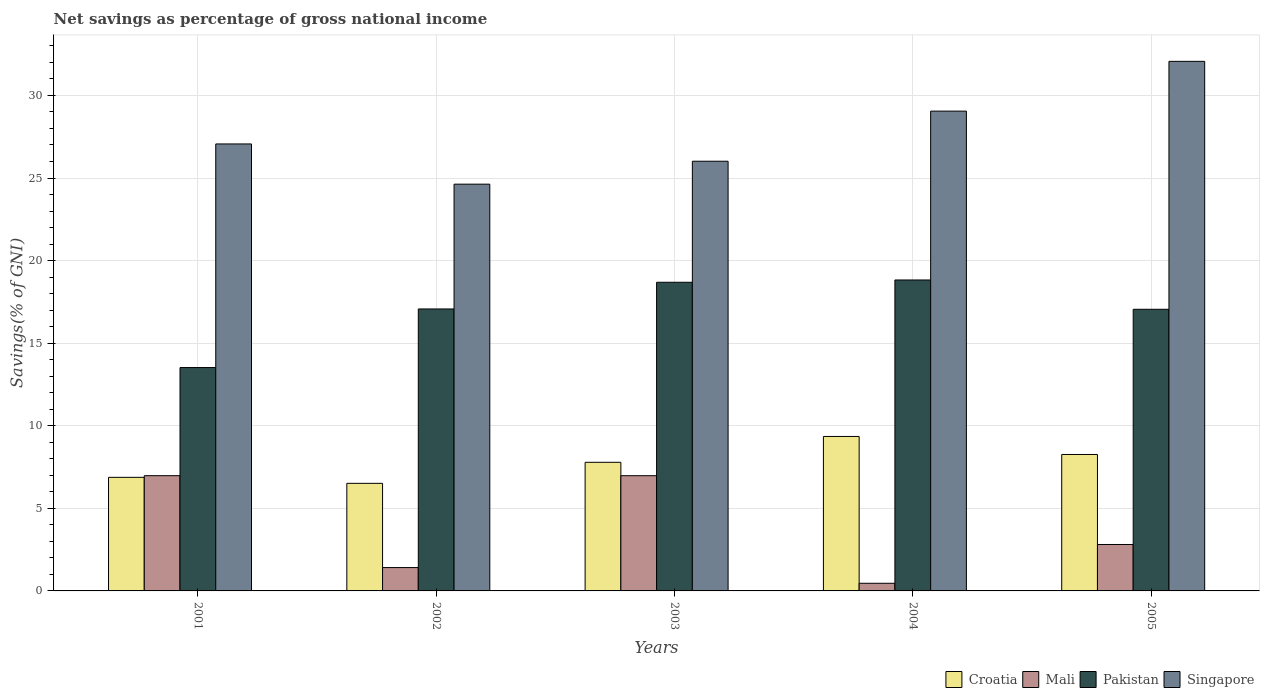How many bars are there on the 3rd tick from the right?
Keep it short and to the point. 4. What is the label of the 1st group of bars from the left?
Offer a terse response. 2001. In how many cases, is the number of bars for a given year not equal to the number of legend labels?
Your answer should be compact. 0. What is the total savings in Mali in 2003?
Make the answer very short. 6.98. Across all years, what is the maximum total savings in Singapore?
Offer a terse response. 32.06. Across all years, what is the minimum total savings in Singapore?
Offer a very short reply. 24.63. In which year was the total savings in Mali maximum?
Your response must be concise. 2001. What is the total total savings in Pakistan in the graph?
Your answer should be very brief. 85.16. What is the difference between the total savings in Singapore in 2003 and that in 2004?
Provide a succinct answer. -3.03. What is the difference between the total savings in Singapore in 2005 and the total savings in Mali in 2004?
Provide a short and direct response. 31.6. What is the average total savings in Croatia per year?
Keep it short and to the point. 7.76. In the year 2005, what is the difference between the total savings in Singapore and total savings in Croatia?
Provide a short and direct response. 23.8. What is the ratio of the total savings in Singapore in 2001 to that in 2005?
Provide a short and direct response. 0.84. Is the total savings in Croatia in 2002 less than that in 2003?
Offer a terse response. Yes. Is the difference between the total savings in Singapore in 2002 and 2005 greater than the difference between the total savings in Croatia in 2002 and 2005?
Your answer should be very brief. No. What is the difference between the highest and the second highest total savings in Croatia?
Ensure brevity in your answer.  1.09. What is the difference between the highest and the lowest total savings in Singapore?
Your answer should be compact. 7.44. Is it the case that in every year, the sum of the total savings in Mali and total savings in Pakistan is greater than the total savings in Singapore?
Provide a short and direct response. No. How many bars are there?
Ensure brevity in your answer.  20. How are the legend labels stacked?
Ensure brevity in your answer.  Horizontal. What is the title of the graph?
Your response must be concise. Net savings as percentage of gross national income. Does "Israel" appear as one of the legend labels in the graph?
Your answer should be very brief. No. What is the label or title of the Y-axis?
Your answer should be very brief. Savings(% of GNI). What is the Savings(% of GNI) in Croatia in 2001?
Your answer should be very brief. 6.88. What is the Savings(% of GNI) of Mali in 2001?
Your response must be concise. 6.98. What is the Savings(% of GNI) in Pakistan in 2001?
Your answer should be very brief. 13.52. What is the Savings(% of GNI) in Singapore in 2001?
Your answer should be compact. 27.06. What is the Savings(% of GNI) in Croatia in 2002?
Keep it short and to the point. 6.51. What is the Savings(% of GNI) of Mali in 2002?
Provide a succinct answer. 1.41. What is the Savings(% of GNI) in Pakistan in 2002?
Keep it short and to the point. 17.07. What is the Savings(% of GNI) of Singapore in 2002?
Your response must be concise. 24.63. What is the Savings(% of GNI) of Croatia in 2003?
Your response must be concise. 7.79. What is the Savings(% of GNI) in Mali in 2003?
Provide a short and direct response. 6.98. What is the Savings(% of GNI) in Pakistan in 2003?
Your answer should be very brief. 18.69. What is the Savings(% of GNI) in Singapore in 2003?
Your answer should be very brief. 26.02. What is the Savings(% of GNI) of Croatia in 2004?
Provide a succinct answer. 9.35. What is the Savings(% of GNI) in Mali in 2004?
Keep it short and to the point. 0.46. What is the Savings(% of GNI) of Pakistan in 2004?
Provide a short and direct response. 18.83. What is the Savings(% of GNI) in Singapore in 2004?
Provide a short and direct response. 29.05. What is the Savings(% of GNI) of Croatia in 2005?
Provide a succinct answer. 8.26. What is the Savings(% of GNI) in Mali in 2005?
Your response must be concise. 2.81. What is the Savings(% of GNI) of Pakistan in 2005?
Make the answer very short. 17.05. What is the Savings(% of GNI) in Singapore in 2005?
Your response must be concise. 32.06. Across all years, what is the maximum Savings(% of GNI) of Croatia?
Give a very brief answer. 9.35. Across all years, what is the maximum Savings(% of GNI) of Mali?
Your response must be concise. 6.98. Across all years, what is the maximum Savings(% of GNI) of Pakistan?
Your response must be concise. 18.83. Across all years, what is the maximum Savings(% of GNI) in Singapore?
Your answer should be compact. 32.06. Across all years, what is the minimum Savings(% of GNI) of Croatia?
Provide a succinct answer. 6.51. Across all years, what is the minimum Savings(% of GNI) in Mali?
Your answer should be compact. 0.46. Across all years, what is the minimum Savings(% of GNI) in Pakistan?
Provide a short and direct response. 13.52. Across all years, what is the minimum Savings(% of GNI) in Singapore?
Your answer should be very brief. 24.63. What is the total Savings(% of GNI) of Croatia in the graph?
Give a very brief answer. 38.79. What is the total Savings(% of GNI) in Mali in the graph?
Give a very brief answer. 18.64. What is the total Savings(% of GNI) of Pakistan in the graph?
Give a very brief answer. 85.16. What is the total Savings(% of GNI) in Singapore in the graph?
Your response must be concise. 138.82. What is the difference between the Savings(% of GNI) in Croatia in 2001 and that in 2002?
Provide a short and direct response. 0.36. What is the difference between the Savings(% of GNI) in Mali in 2001 and that in 2002?
Give a very brief answer. 5.56. What is the difference between the Savings(% of GNI) in Pakistan in 2001 and that in 2002?
Give a very brief answer. -3.55. What is the difference between the Savings(% of GNI) in Singapore in 2001 and that in 2002?
Your response must be concise. 2.44. What is the difference between the Savings(% of GNI) in Croatia in 2001 and that in 2003?
Offer a very short reply. -0.91. What is the difference between the Savings(% of GNI) of Pakistan in 2001 and that in 2003?
Your answer should be very brief. -5.16. What is the difference between the Savings(% of GNI) of Singapore in 2001 and that in 2003?
Make the answer very short. 1.05. What is the difference between the Savings(% of GNI) in Croatia in 2001 and that in 2004?
Ensure brevity in your answer.  -2.47. What is the difference between the Savings(% of GNI) in Mali in 2001 and that in 2004?
Your response must be concise. 6.51. What is the difference between the Savings(% of GNI) of Pakistan in 2001 and that in 2004?
Your response must be concise. -5.3. What is the difference between the Savings(% of GNI) of Singapore in 2001 and that in 2004?
Give a very brief answer. -1.99. What is the difference between the Savings(% of GNI) in Croatia in 2001 and that in 2005?
Give a very brief answer. -1.38. What is the difference between the Savings(% of GNI) in Mali in 2001 and that in 2005?
Provide a succinct answer. 4.17. What is the difference between the Savings(% of GNI) of Pakistan in 2001 and that in 2005?
Give a very brief answer. -3.53. What is the difference between the Savings(% of GNI) in Singapore in 2001 and that in 2005?
Offer a very short reply. -5. What is the difference between the Savings(% of GNI) of Croatia in 2002 and that in 2003?
Your answer should be very brief. -1.27. What is the difference between the Savings(% of GNI) of Mali in 2002 and that in 2003?
Keep it short and to the point. -5.56. What is the difference between the Savings(% of GNI) of Pakistan in 2002 and that in 2003?
Give a very brief answer. -1.62. What is the difference between the Savings(% of GNI) of Singapore in 2002 and that in 2003?
Give a very brief answer. -1.39. What is the difference between the Savings(% of GNI) of Croatia in 2002 and that in 2004?
Give a very brief answer. -2.84. What is the difference between the Savings(% of GNI) of Mali in 2002 and that in 2004?
Your answer should be very brief. 0.95. What is the difference between the Savings(% of GNI) in Pakistan in 2002 and that in 2004?
Your answer should be compact. -1.75. What is the difference between the Savings(% of GNI) of Singapore in 2002 and that in 2004?
Your answer should be compact. -4.42. What is the difference between the Savings(% of GNI) in Croatia in 2002 and that in 2005?
Offer a terse response. -1.75. What is the difference between the Savings(% of GNI) of Mali in 2002 and that in 2005?
Ensure brevity in your answer.  -1.4. What is the difference between the Savings(% of GNI) of Pakistan in 2002 and that in 2005?
Your answer should be compact. 0.02. What is the difference between the Savings(% of GNI) of Singapore in 2002 and that in 2005?
Ensure brevity in your answer.  -7.44. What is the difference between the Savings(% of GNI) of Croatia in 2003 and that in 2004?
Your response must be concise. -1.56. What is the difference between the Savings(% of GNI) in Mali in 2003 and that in 2004?
Your response must be concise. 6.51. What is the difference between the Savings(% of GNI) of Pakistan in 2003 and that in 2004?
Ensure brevity in your answer.  -0.14. What is the difference between the Savings(% of GNI) in Singapore in 2003 and that in 2004?
Give a very brief answer. -3.03. What is the difference between the Savings(% of GNI) of Croatia in 2003 and that in 2005?
Provide a short and direct response. -0.47. What is the difference between the Savings(% of GNI) of Mali in 2003 and that in 2005?
Provide a short and direct response. 4.17. What is the difference between the Savings(% of GNI) of Pakistan in 2003 and that in 2005?
Make the answer very short. 1.64. What is the difference between the Savings(% of GNI) in Singapore in 2003 and that in 2005?
Offer a very short reply. -6.05. What is the difference between the Savings(% of GNI) of Croatia in 2004 and that in 2005?
Offer a terse response. 1.09. What is the difference between the Savings(% of GNI) of Mali in 2004 and that in 2005?
Your answer should be very brief. -2.35. What is the difference between the Savings(% of GNI) in Pakistan in 2004 and that in 2005?
Your answer should be compact. 1.77. What is the difference between the Savings(% of GNI) of Singapore in 2004 and that in 2005?
Your response must be concise. -3.01. What is the difference between the Savings(% of GNI) in Croatia in 2001 and the Savings(% of GNI) in Mali in 2002?
Offer a terse response. 5.46. What is the difference between the Savings(% of GNI) in Croatia in 2001 and the Savings(% of GNI) in Pakistan in 2002?
Make the answer very short. -10.2. What is the difference between the Savings(% of GNI) of Croatia in 2001 and the Savings(% of GNI) of Singapore in 2002?
Offer a terse response. -17.75. What is the difference between the Savings(% of GNI) of Mali in 2001 and the Savings(% of GNI) of Pakistan in 2002?
Provide a short and direct response. -10.09. What is the difference between the Savings(% of GNI) in Mali in 2001 and the Savings(% of GNI) in Singapore in 2002?
Offer a terse response. -17.65. What is the difference between the Savings(% of GNI) of Pakistan in 2001 and the Savings(% of GNI) of Singapore in 2002?
Provide a short and direct response. -11.1. What is the difference between the Savings(% of GNI) in Croatia in 2001 and the Savings(% of GNI) in Mali in 2003?
Provide a succinct answer. -0.1. What is the difference between the Savings(% of GNI) in Croatia in 2001 and the Savings(% of GNI) in Pakistan in 2003?
Make the answer very short. -11.81. What is the difference between the Savings(% of GNI) of Croatia in 2001 and the Savings(% of GNI) of Singapore in 2003?
Make the answer very short. -19.14. What is the difference between the Savings(% of GNI) in Mali in 2001 and the Savings(% of GNI) in Pakistan in 2003?
Give a very brief answer. -11.71. What is the difference between the Savings(% of GNI) of Mali in 2001 and the Savings(% of GNI) of Singapore in 2003?
Provide a short and direct response. -19.04. What is the difference between the Savings(% of GNI) in Pakistan in 2001 and the Savings(% of GNI) in Singapore in 2003?
Ensure brevity in your answer.  -12.49. What is the difference between the Savings(% of GNI) in Croatia in 2001 and the Savings(% of GNI) in Mali in 2004?
Offer a terse response. 6.41. What is the difference between the Savings(% of GNI) in Croatia in 2001 and the Savings(% of GNI) in Pakistan in 2004?
Ensure brevity in your answer.  -11.95. What is the difference between the Savings(% of GNI) of Croatia in 2001 and the Savings(% of GNI) of Singapore in 2004?
Keep it short and to the point. -22.17. What is the difference between the Savings(% of GNI) of Mali in 2001 and the Savings(% of GNI) of Pakistan in 2004?
Provide a succinct answer. -11.85. What is the difference between the Savings(% of GNI) of Mali in 2001 and the Savings(% of GNI) of Singapore in 2004?
Give a very brief answer. -22.07. What is the difference between the Savings(% of GNI) in Pakistan in 2001 and the Savings(% of GNI) in Singapore in 2004?
Provide a short and direct response. -15.53. What is the difference between the Savings(% of GNI) in Croatia in 2001 and the Savings(% of GNI) in Mali in 2005?
Make the answer very short. 4.07. What is the difference between the Savings(% of GNI) of Croatia in 2001 and the Savings(% of GNI) of Pakistan in 2005?
Ensure brevity in your answer.  -10.18. What is the difference between the Savings(% of GNI) in Croatia in 2001 and the Savings(% of GNI) in Singapore in 2005?
Give a very brief answer. -25.19. What is the difference between the Savings(% of GNI) of Mali in 2001 and the Savings(% of GNI) of Pakistan in 2005?
Your answer should be compact. -10.07. What is the difference between the Savings(% of GNI) in Mali in 2001 and the Savings(% of GNI) in Singapore in 2005?
Make the answer very short. -25.09. What is the difference between the Savings(% of GNI) in Pakistan in 2001 and the Savings(% of GNI) in Singapore in 2005?
Give a very brief answer. -18.54. What is the difference between the Savings(% of GNI) of Croatia in 2002 and the Savings(% of GNI) of Mali in 2003?
Make the answer very short. -0.46. What is the difference between the Savings(% of GNI) in Croatia in 2002 and the Savings(% of GNI) in Pakistan in 2003?
Keep it short and to the point. -12.17. What is the difference between the Savings(% of GNI) in Croatia in 2002 and the Savings(% of GNI) in Singapore in 2003?
Keep it short and to the point. -19.5. What is the difference between the Savings(% of GNI) in Mali in 2002 and the Savings(% of GNI) in Pakistan in 2003?
Ensure brevity in your answer.  -17.27. What is the difference between the Savings(% of GNI) in Mali in 2002 and the Savings(% of GNI) in Singapore in 2003?
Offer a terse response. -24.6. What is the difference between the Savings(% of GNI) of Pakistan in 2002 and the Savings(% of GNI) of Singapore in 2003?
Your answer should be very brief. -8.94. What is the difference between the Savings(% of GNI) of Croatia in 2002 and the Savings(% of GNI) of Mali in 2004?
Provide a short and direct response. 6.05. What is the difference between the Savings(% of GNI) in Croatia in 2002 and the Savings(% of GNI) in Pakistan in 2004?
Give a very brief answer. -12.31. What is the difference between the Savings(% of GNI) of Croatia in 2002 and the Savings(% of GNI) of Singapore in 2004?
Your answer should be compact. -22.54. What is the difference between the Savings(% of GNI) in Mali in 2002 and the Savings(% of GNI) in Pakistan in 2004?
Your answer should be compact. -17.41. What is the difference between the Savings(% of GNI) in Mali in 2002 and the Savings(% of GNI) in Singapore in 2004?
Give a very brief answer. -27.64. What is the difference between the Savings(% of GNI) in Pakistan in 2002 and the Savings(% of GNI) in Singapore in 2004?
Give a very brief answer. -11.98. What is the difference between the Savings(% of GNI) in Croatia in 2002 and the Savings(% of GNI) in Mali in 2005?
Offer a very short reply. 3.7. What is the difference between the Savings(% of GNI) in Croatia in 2002 and the Savings(% of GNI) in Pakistan in 2005?
Provide a short and direct response. -10.54. What is the difference between the Savings(% of GNI) of Croatia in 2002 and the Savings(% of GNI) of Singapore in 2005?
Your answer should be very brief. -25.55. What is the difference between the Savings(% of GNI) in Mali in 2002 and the Savings(% of GNI) in Pakistan in 2005?
Provide a succinct answer. -15.64. What is the difference between the Savings(% of GNI) of Mali in 2002 and the Savings(% of GNI) of Singapore in 2005?
Provide a succinct answer. -30.65. What is the difference between the Savings(% of GNI) of Pakistan in 2002 and the Savings(% of GNI) of Singapore in 2005?
Ensure brevity in your answer.  -14.99. What is the difference between the Savings(% of GNI) in Croatia in 2003 and the Savings(% of GNI) in Mali in 2004?
Your answer should be compact. 7.32. What is the difference between the Savings(% of GNI) in Croatia in 2003 and the Savings(% of GNI) in Pakistan in 2004?
Your answer should be compact. -11.04. What is the difference between the Savings(% of GNI) in Croatia in 2003 and the Savings(% of GNI) in Singapore in 2004?
Provide a succinct answer. -21.26. What is the difference between the Savings(% of GNI) in Mali in 2003 and the Savings(% of GNI) in Pakistan in 2004?
Your answer should be very brief. -11.85. What is the difference between the Savings(% of GNI) of Mali in 2003 and the Savings(% of GNI) of Singapore in 2004?
Make the answer very short. -22.07. What is the difference between the Savings(% of GNI) in Pakistan in 2003 and the Savings(% of GNI) in Singapore in 2004?
Keep it short and to the point. -10.36. What is the difference between the Savings(% of GNI) in Croatia in 2003 and the Savings(% of GNI) in Mali in 2005?
Your response must be concise. 4.98. What is the difference between the Savings(% of GNI) in Croatia in 2003 and the Savings(% of GNI) in Pakistan in 2005?
Your response must be concise. -9.27. What is the difference between the Savings(% of GNI) of Croatia in 2003 and the Savings(% of GNI) of Singapore in 2005?
Your answer should be very brief. -24.28. What is the difference between the Savings(% of GNI) of Mali in 2003 and the Savings(% of GNI) of Pakistan in 2005?
Give a very brief answer. -10.08. What is the difference between the Savings(% of GNI) in Mali in 2003 and the Savings(% of GNI) in Singapore in 2005?
Ensure brevity in your answer.  -25.09. What is the difference between the Savings(% of GNI) in Pakistan in 2003 and the Savings(% of GNI) in Singapore in 2005?
Offer a terse response. -13.38. What is the difference between the Savings(% of GNI) of Croatia in 2004 and the Savings(% of GNI) of Mali in 2005?
Your response must be concise. 6.54. What is the difference between the Savings(% of GNI) in Croatia in 2004 and the Savings(% of GNI) in Pakistan in 2005?
Provide a succinct answer. -7.7. What is the difference between the Savings(% of GNI) of Croatia in 2004 and the Savings(% of GNI) of Singapore in 2005?
Provide a succinct answer. -22.71. What is the difference between the Savings(% of GNI) of Mali in 2004 and the Savings(% of GNI) of Pakistan in 2005?
Provide a short and direct response. -16.59. What is the difference between the Savings(% of GNI) of Mali in 2004 and the Savings(% of GNI) of Singapore in 2005?
Your answer should be compact. -31.6. What is the difference between the Savings(% of GNI) in Pakistan in 2004 and the Savings(% of GNI) in Singapore in 2005?
Keep it short and to the point. -13.24. What is the average Savings(% of GNI) in Croatia per year?
Offer a terse response. 7.76. What is the average Savings(% of GNI) in Mali per year?
Your answer should be very brief. 3.73. What is the average Savings(% of GNI) in Pakistan per year?
Your answer should be compact. 17.03. What is the average Savings(% of GNI) in Singapore per year?
Provide a succinct answer. 27.76. In the year 2001, what is the difference between the Savings(% of GNI) of Croatia and Savings(% of GNI) of Mali?
Make the answer very short. -0.1. In the year 2001, what is the difference between the Savings(% of GNI) of Croatia and Savings(% of GNI) of Pakistan?
Keep it short and to the point. -6.65. In the year 2001, what is the difference between the Savings(% of GNI) in Croatia and Savings(% of GNI) in Singapore?
Ensure brevity in your answer.  -20.19. In the year 2001, what is the difference between the Savings(% of GNI) in Mali and Savings(% of GNI) in Pakistan?
Your response must be concise. -6.55. In the year 2001, what is the difference between the Savings(% of GNI) in Mali and Savings(% of GNI) in Singapore?
Provide a short and direct response. -20.09. In the year 2001, what is the difference between the Savings(% of GNI) in Pakistan and Savings(% of GNI) in Singapore?
Make the answer very short. -13.54. In the year 2002, what is the difference between the Savings(% of GNI) in Croatia and Savings(% of GNI) in Mali?
Your answer should be compact. 5.1. In the year 2002, what is the difference between the Savings(% of GNI) in Croatia and Savings(% of GNI) in Pakistan?
Provide a short and direct response. -10.56. In the year 2002, what is the difference between the Savings(% of GNI) of Croatia and Savings(% of GNI) of Singapore?
Your answer should be compact. -18.11. In the year 2002, what is the difference between the Savings(% of GNI) of Mali and Savings(% of GNI) of Pakistan?
Your answer should be very brief. -15.66. In the year 2002, what is the difference between the Savings(% of GNI) of Mali and Savings(% of GNI) of Singapore?
Offer a terse response. -23.21. In the year 2002, what is the difference between the Savings(% of GNI) of Pakistan and Savings(% of GNI) of Singapore?
Your response must be concise. -7.56. In the year 2003, what is the difference between the Savings(% of GNI) in Croatia and Savings(% of GNI) in Mali?
Provide a short and direct response. 0.81. In the year 2003, what is the difference between the Savings(% of GNI) of Croatia and Savings(% of GNI) of Pakistan?
Ensure brevity in your answer.  -10.9. In the year 2003, what is the difference between the Savings(% of GNI) of Croatia and Savings(% of GNI) of Singapore?
Make the answer very short. -18.23. In the year 2003, what is the difference between the Savings(% of GNI) of Mali and Savings(% of GNI) of Pakistan?
Make the answer very short. -11.71. In the year 2003, what is the difference between the Savings(% of GNI) of Mali and Savings(% of GNI) of Singapore?
Give a very brief answer. -19.04. In the year 2003, what is the difference between the Savings(% of GNI) of Pakistan and Savings(% of GNI) of Singapore?
Your answer should be compact. -7.33. In the year 2004, what is the difference between the Savings(% of GNI) of Croatia and Savings(% of GNI) of Mali?
Provide a succinct answer. 8.89. In the year 2004, what is the difference between the Savings(% of GNI) in Croatia and Savings(% of GNI) in Pakistan?
Make the answer very short. -9.47. In the year 2004, what is the difference between the Savings(% of GNI) of Croatia and Savings(% of GNI) of Singapore?
Offer a terse response. -19.7. In the year 2004, what is the difference between the Savings(% of GNI) of Mali and Savings(% of GNI) of Pakistan?
Ensure brevity in your answer.  -18.36. In the year 2004, what is the difference between the Savings(% of GNI) of Mali and Savings(% of GNI) of Singapore?
Provide a short and direct response. -28.59. In the year 2004, what is the difference between the Savings(% of GNI) of Pakistan and Savings(% of GNI) of Singapore?
Give a very brief answer. -10.22. In the year 2005, what is the difference between the Savings(% of GNI) in Croatia and Savings(% of GNI) in Mali?
Offer a terse response. 5.45. In the year 2005, what is the difference between the Savings(% of GNI) of Croatia and Savings(% of GNI) of Pakistan?
Your answer should be very brief. -8.79. In the year 2005, what is the difference between the Savings(% of GNI) in Croatia and Savings(% of GNI) in Singapore?
Offer a very short reply. -23.8. In the year 2005, what is the difference between the Savings(% of GNI) in Mali and Savings(% of GNI) in Pakistan?
Keep it short and to the point. -14.24. In the year 2005, what is the difference between the Savings(% of GNI) of Mali and Savings(% of GNI) of Singapore?
Ensure brevity in your answer.  -29.25. In the year 2005, what is the difference between the Savings(% of GNI) of Pakistan and Savings(% of GNI) of Singapore?
Keep it short and to the point. -15.01. What is the ratio of the Savings(% of GNI) of Croatia in 2001 to that in 2002?
Offer a terse response. 1.06. What is the ratio of the Savings(% of GNI) of Mali in 2001 to that in 2002?
Your answer should be very brief. 4.93. What is the ratio of the Savings(% of GNI) in Pakistan in 2001 to that in 2002?
Your answer should be compact. 0.79. What is the ratio of the Savings(% of GNI) in Singapore in 2001 to that in 2002?
Ensure brevity in your answer.  1.1. What is the ratio of the Savings(% of GNI) of Croatia in 2001 to that in 2003?
Your answer should be compact. 0.88. What is the ratio of the Savings(% of GNI) of Mali in 2001 to that in 2003?
Give a very brief answer. 1. What is the ratio of the Savings(% of GNI) in Pakistan in 2001 to that in 2003?
Ensure brevity in your answer.  0.72. What is the ratio of the Savings(% of GNI) of Singapore in 2001 to that in 2003?
Provide a succinct answer. 1.04. What is the ratio of the Savings(% of GNI) of Croatia in 2001 to that in 2004?
Provide a succinct answer. 0.74. What is the ratio of the Savings(% of GNI) of Mali in 2001 to that in 2004?
Your response must be concise. 15.08. What is the ratio of the Savings(% of GNI) in Pakistan in 2001 to that in 2004?
Offer a terse response. 0.72. What is the ratio of the Savings(% of GNI) of Singapore in 2001 to that in 2004?
Provide a short and direct response. 0.93. What is the ratio of the Savings(% of GNI) in Croatia in 2001 to that in 2005?
Provide a short and direct response. 0.83. What is the ratio of the Savings(% of GNI) of Mali in 2001 to that in 2005?
Your response must be concise. 2.48. What is the ratio of the Savings(% of GNI) in Pakistan in 2001 to that in 2005?
Make the answer very short. 0.79. What is the ratio of the Savings(% of GNI) in Singapore in 2001 to that in 2005?
Make the answer very short. 0.84. What is the ratio of the Savings(% of GNI) of Croatia in 2002 to that in 2003?
Offer a very short reply. 0.84. What is the ratio of the Savings(% of GNI) in Mali in 2002 to that in 2003?
Offer a terse response. 0.2. What is the ratio of the Savings(% of GNI) in Pakistan in 2002 to that in 2003?
Ensure brevity in your answer.  0.91. What is the ratio of the Savings(% of GNI) in Singapore in 2002 to that in 2003?
Your answer should be compact. 0.95. What is the ratio of the Savings(% of GNI) of Croatia in 2002 to that in 2004?
Give a very brief answer. 0.7. What is the ratio of the Savings(% of GNI) of Mali in 2002 to that in 2004?
Your response must be concise. 3.06. What is the ratio of the Savings(% of GNI) of Pakistan in 2002 to that in 2004?
Give a very brief answer. 0.91. What is the ratio of the Savings(% of GNI) of Singapore in 2002 to that in 2004?
Make the answer very short. 0.85. What is the ratio of the Savings(% of GNI) of Croatia in 2002 to that in 2005?
Your answer should be very brief. 0.79. What is the ratio of the Savings(% of GNI) of Mali in 2002 to that in 2005?
Keep it short and to the point. 0.5. What is the ratio of the Savings(% of GNI) of Singapore in 2002 to that in 2005?
Your response must be concise. 0.77. What is the ratio of the Savings(% of GNI) of Croatia in 2003 to that in 2004?
Your response must be concise. 0.83. What is the ratio of the Savings(% of GNI) of Mali in 2003 to that in 2004?
Provide a succinct answer. 15.08. What is the ratio of the Savings(% of GNI) of Singapore in 2003 to that in 2004?
Offer a terse response. 0.9. What is the ratio of the Savings(% of GNI) in Croatia in 2003 to that in 2005?
Your answer should be very brief. 0.94. What is the ratio of the Savings(% of GNI) in Mali in 2003 to that in 2005?
Offer a terse response. 2.48. What is the ratio of the Savings(% of GNI) of Pakistan in 2003 to that in 2005?
Make the answer very short. 1.1. What is the ratio of the Savings(% of GNI) in Singapore in 2003 to that in 2005?
Offer a terse response. 0.81. What is the ratio of the Savings(% of GNI) of Croatia in 2004 to that in 2005?
Your answer should be compact. 1.13. What is the ratio of the Savings(% of GNI) in Mali in 2004 to that in 2005?
Ensure brevity in your answer.  0.16. What is the ratio of the Savings(% of GNI) of Pakistan in 2004 to that in 2005?
Make the answer very short. 1.1. What is the ratio of the Savings(% of GNI) of Singapore in 2004 to that in 2005?
Your answer should be compact. 0.91. What is the difference between the highest and the second highest Savings(% of GNI) of Croatia?
Provide a succinct answer. 1.09. What is the difference between the highest and the second highest Savings(% of GNI) of Mali?
Your answer should be compact. 0. What is the difference between the highest and the second highest Savings(% of GNI) in Pakistan?
Offer a very short reply. 0.14. What is the difference between the highest and the second highest Savings(% of GNI) in Singapore?
Your answer should be very brief. 3.01. What is the difference between the highest and the lowest Savings(% of GNI) of Croatia?
Provide a short and direct response. 2.84. What is the difference between the highest and the lowest Savings(% of GNI) of Mali?
Your answer should be very brief. 6.51. What is the difference between the highest and the lowest Savings(% of GNI) in Pakistan?
Keep it short and to the point. 5.3. What is the difference between the highest and the lowest Savings(% of GNI) of Singapore?
Provide a short and direct response. 7.44. 